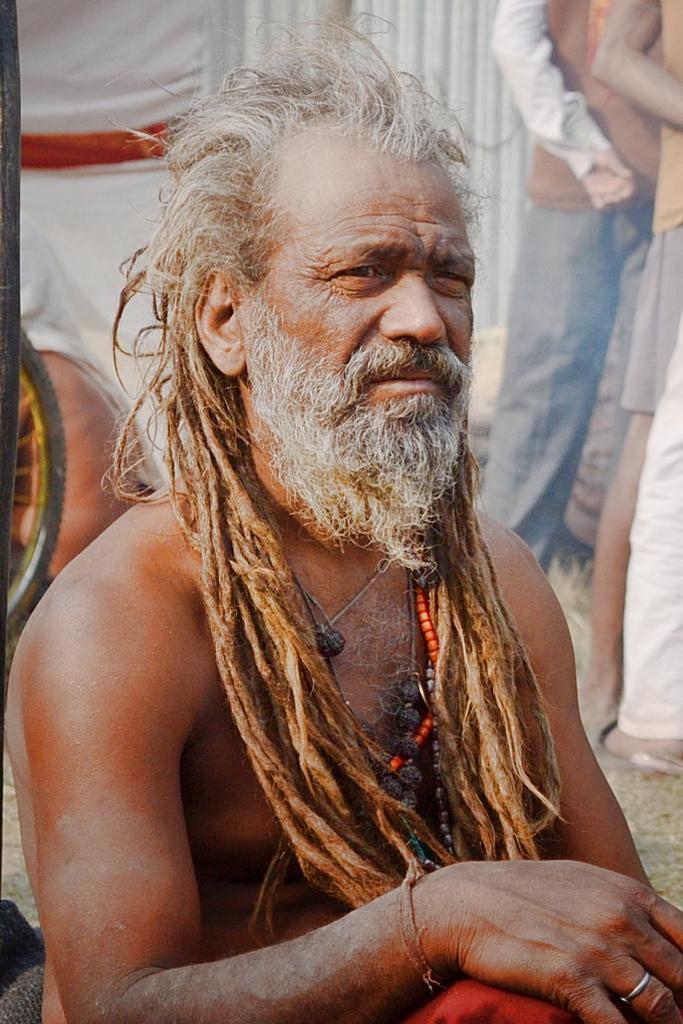Please provide a concise description of this image. In this image I can see a person. On the left side I can see a wheel. In the background, I can see three people. 